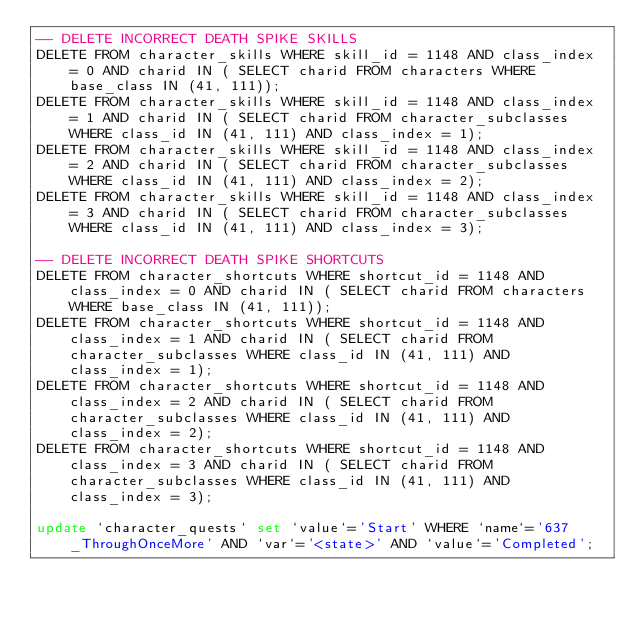Convert code to text. <code><loc_0><loc_0><loc_500><loc_500><_SQL_>-- DELETE INCORRECT DEATH SPIKE SKILLS
DELETE FROM character_skills WHERE skill_id = 1148 AND class_index = 0 AND charid IN ( SELECT charid FROM characters WHERE base_class IN (41, 111));
DELETE FROM character_skills WHERE skill_id = 1148 AND class_index = 1 AND charid IN ( SELECT charid FROM character_subclasses WHERE class_id IN (41, 111) AND class_index = 1);
DELETE FROM character_skills WHERE skill_id = 1148 AND class_index = 2 AND charid IN ( SELECT charid FROM character_subclasses WHERE class_id IN (41, 111) AND class_index = 2);
DELETE FROM character_skills WHERE skill_id = 1148 AND class_index = 3 AND charid IN ( SELECT charid FROM character_subclasses WHERE class_id IN (41, 111) AND class_index = 3);

-- DELETE INCORRECT DEATH SPIKE SHORTCUTS
DELETE FROM character_shortcuts WHERE shortcut_id = 1148 AND class_index = 0 AND charid IN ( SELECT charid FROM characters WHERE base_class IN (41, 111));
DELETE FROM character_shortcuts WHERE shortcut_id = 1148 AND class_index = 1 AND charid IN ( SELECT charid FROM character_subclasses WHERE class_id IN (41, 111) AND class_index = 1);
DELETE FROM character_shortcuts WHERE shortcut_id = 1148 AND class_index = 2 AND charid IN ( SELECT charid FROM character_subclasses WHERE class_id IN (41, 111) AND class_index = 2);
DELETE FROM character_shortcuts WHERE shortcut_id = 1148 AND class_index = 3 AND charid IN ( SELECT charid FROM character_subclasses WHERE class_id IN (41, 111) AND class_index = 3);

update `character_quests` set `value`='Start' WHERE `name`='637_ThroughOnceMore' AND `var`='<state>' AND `value`='Completed';</code> 